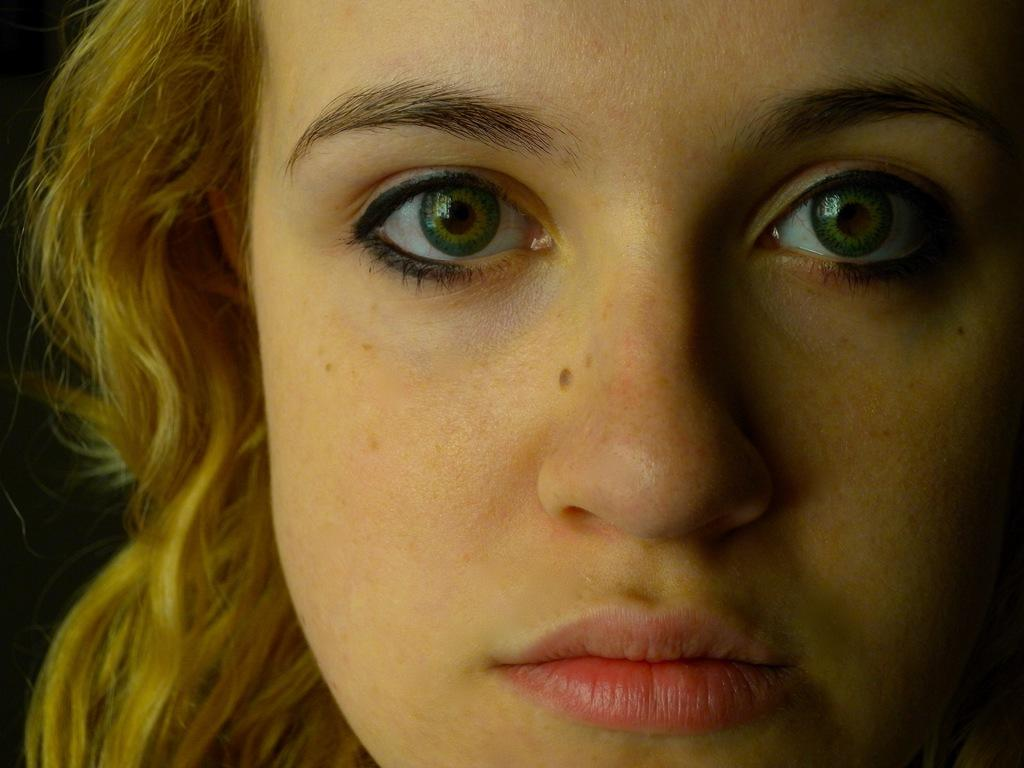Who is the main subject in the image? There is a lady in the center of the image. What type of cabbage is the lady holding in the image? There is no cabbage present in the image; the lady is the main subject. How many circles can be seen around the lady in the image? There is no mention of circles in the image; the focus is on the lady in the center. 